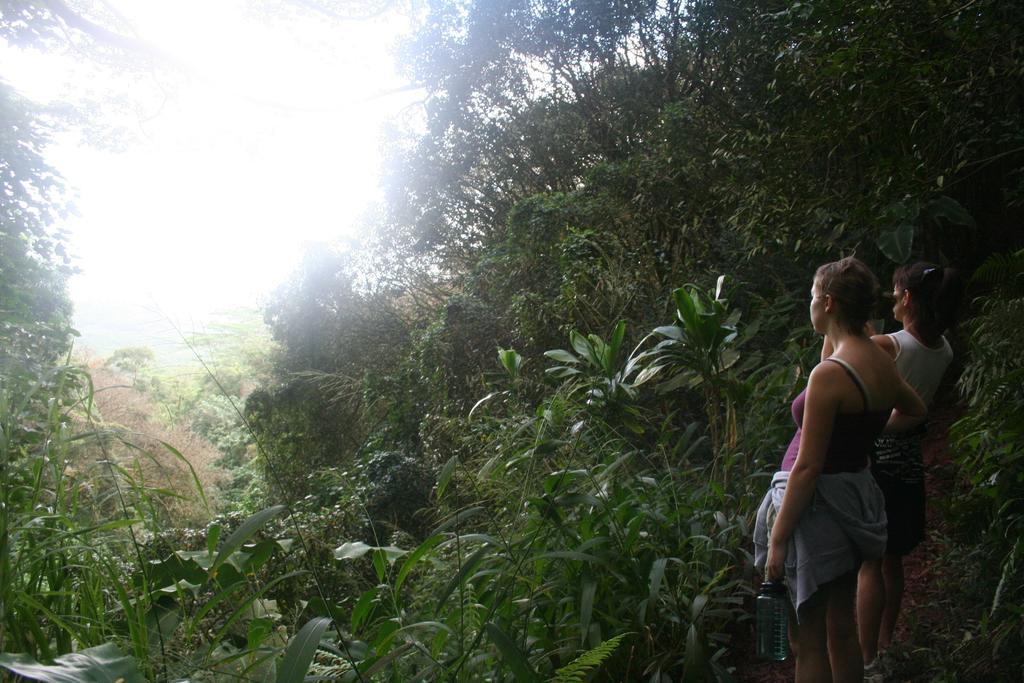In one or two sentences, can you explain what this image depicts? In the picture I can see two women are standing on the ground. In the background I can see plants and trees. 